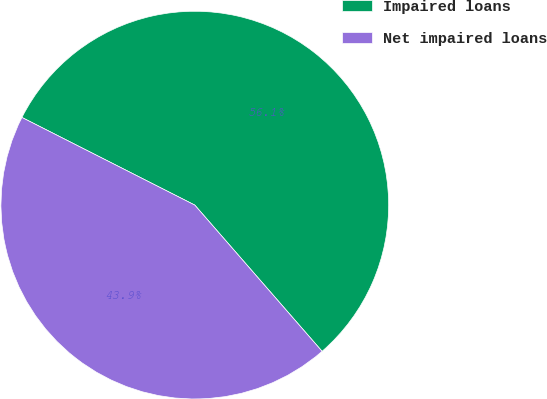Convert chart. <chart><loc_0><loc_0><loc_500><loc_500><pie_chart><fcel>Impaired loans<fcel>Net impaired loans<nl><fcel>56.13%<fcel>43.87%<nl></chart> 